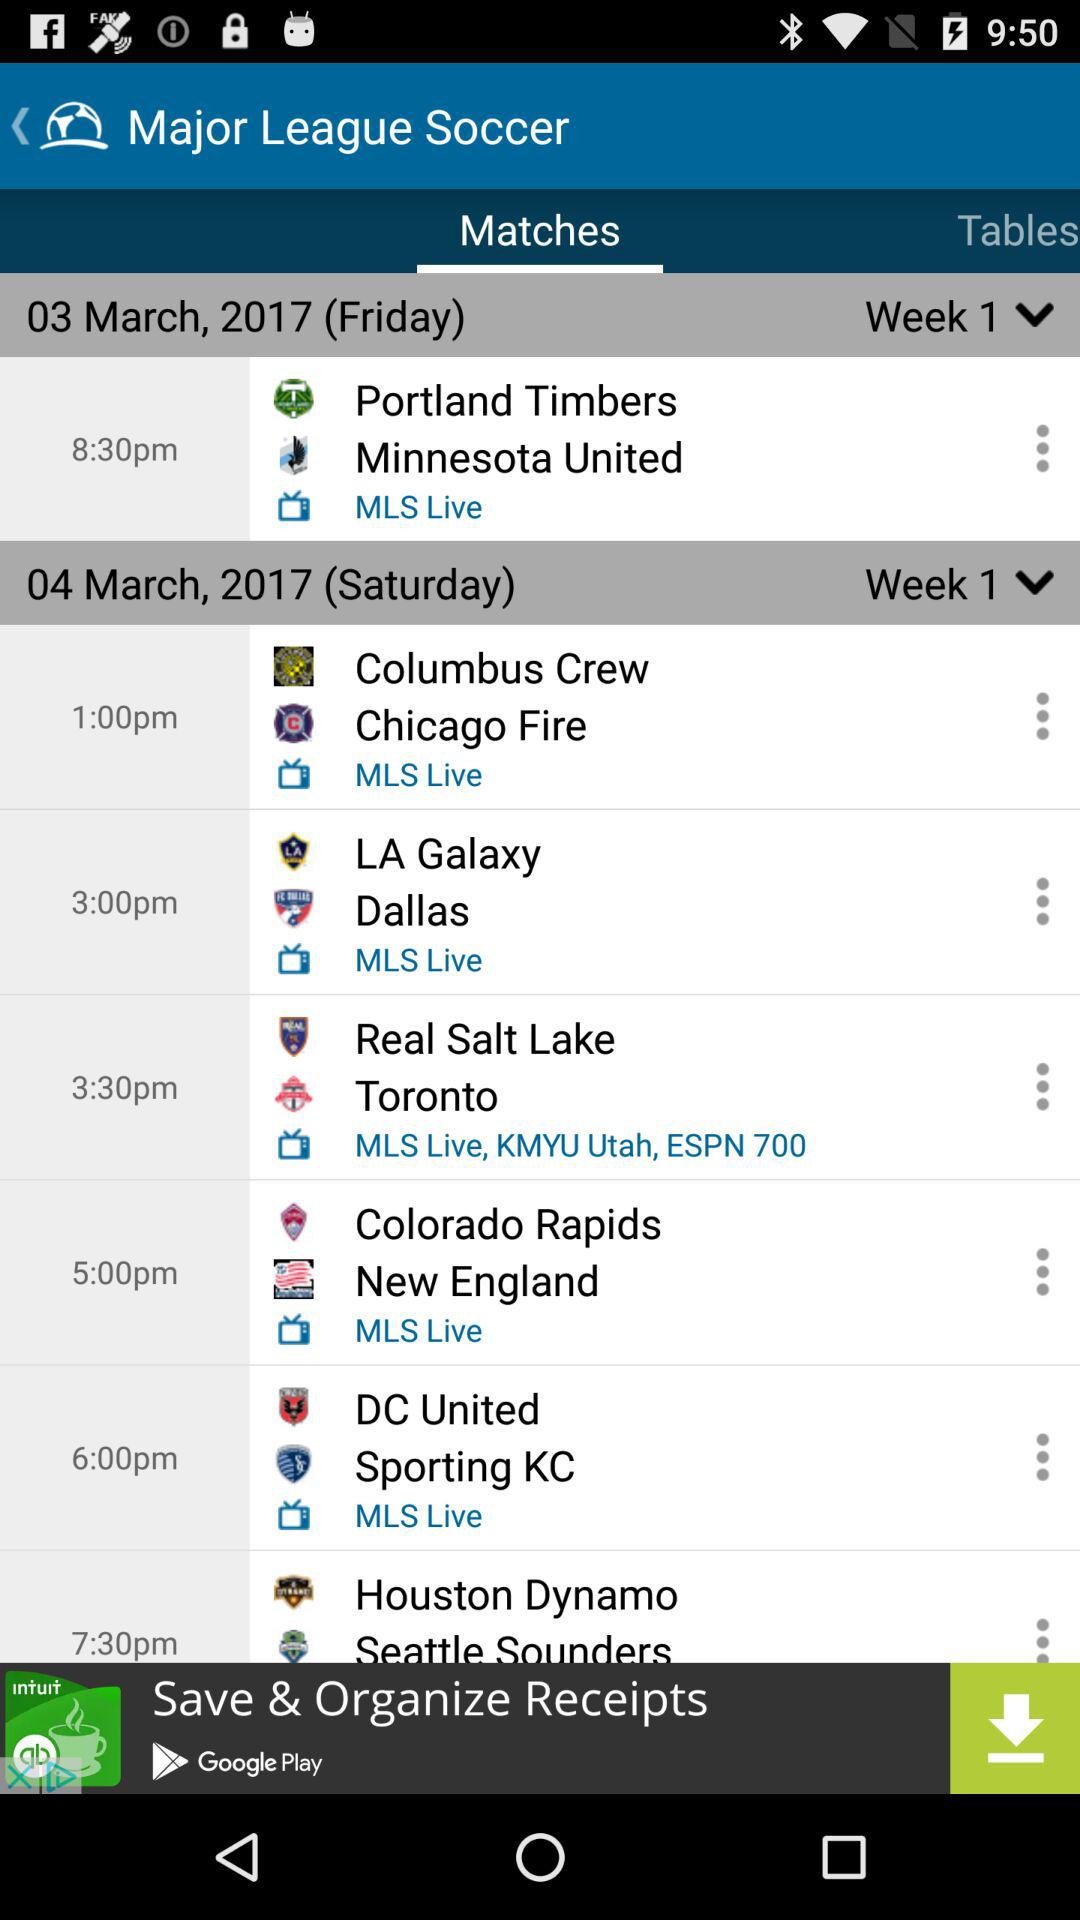What is the match timing of DC United vs. Sporting KC? The match time is "6:00 PM". 